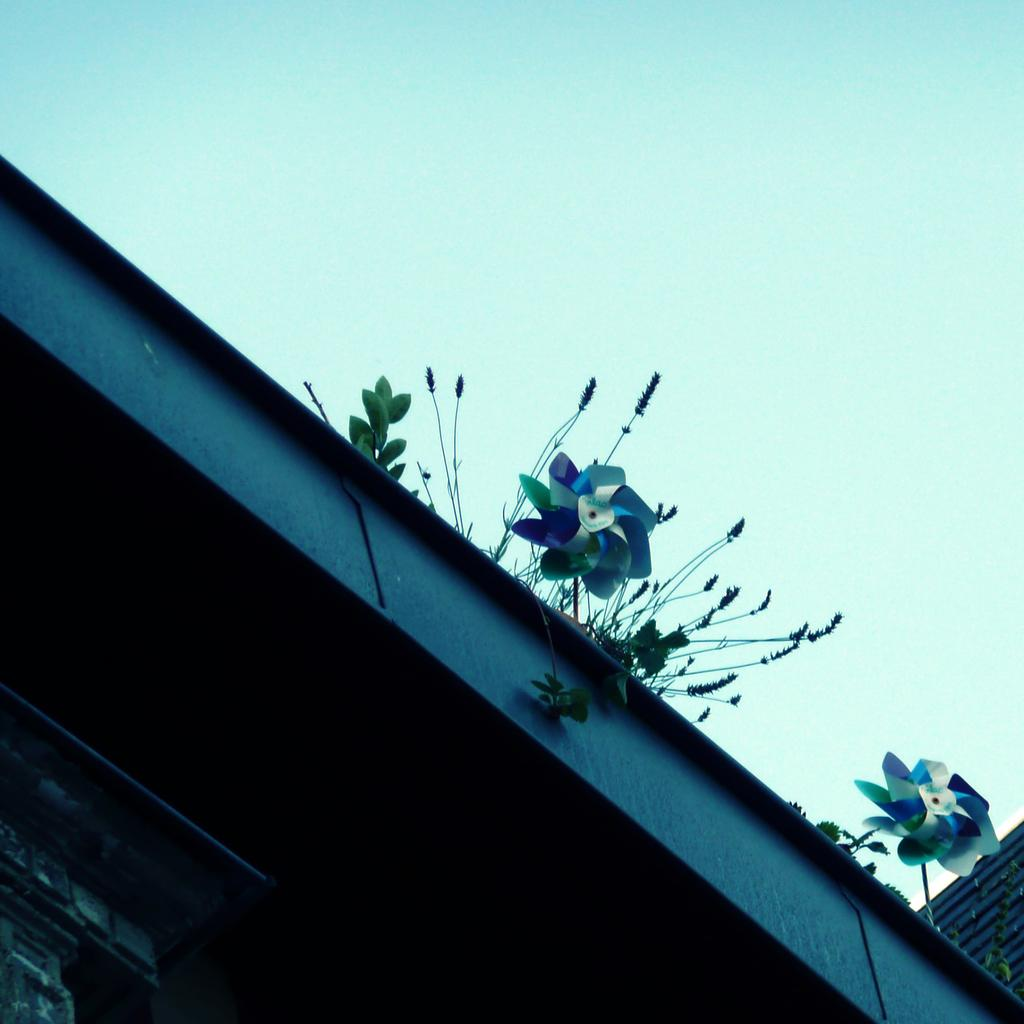What structure is located at the bottom of the image? There is a building at the bottom of the image. What can be seen in the center of the image? There are fan-like objects and plants in the center of the image. What is visible at the top of the image? The sky is visible at the top of the image. Can you see the brain of the person in the image? There is no person present in the image, and therefore no brain can be seen. Is there any smoke visible in the image? There is no smoke present in the image. 